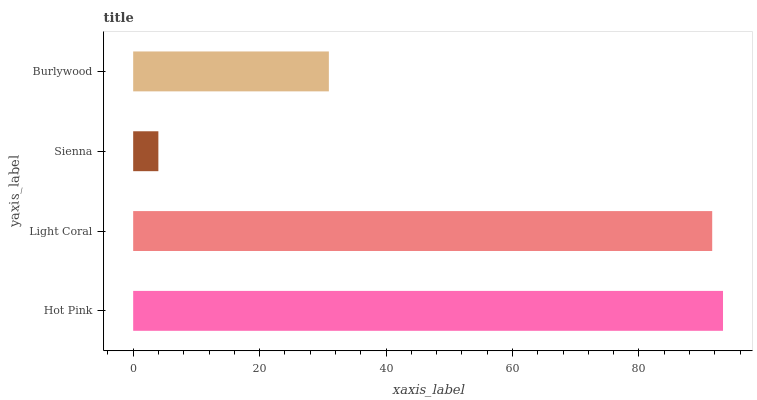Is Sienna the minimum?
Answer yes or no. Yes. Is Hot Pink the maximum?
Answer yes or no. Yes. Is Light Coral the minimum?
Answer yes or no. No. Is Light Coral the maximum?
Answer yes or no. No. Is Hot Pink greater than Light Coral?
Answer yes or no. Yes. Is Light Coral less than Hot Pink?
Answer yes or no. Yes. Is Light Coral greater than Hot Pink?
Answer yes or no. No. Is Hot Pink less than Light Coral?
Answer yes or no. No. Is Light Coral the high median?
Answer yes or no. Yes. Is Burlywood the low median?
Answer yes or no. Yes. Is Hot Pink the high median?
Answer yes or no. No. Is Light Coral the low median?
Answer yes or no. No. 